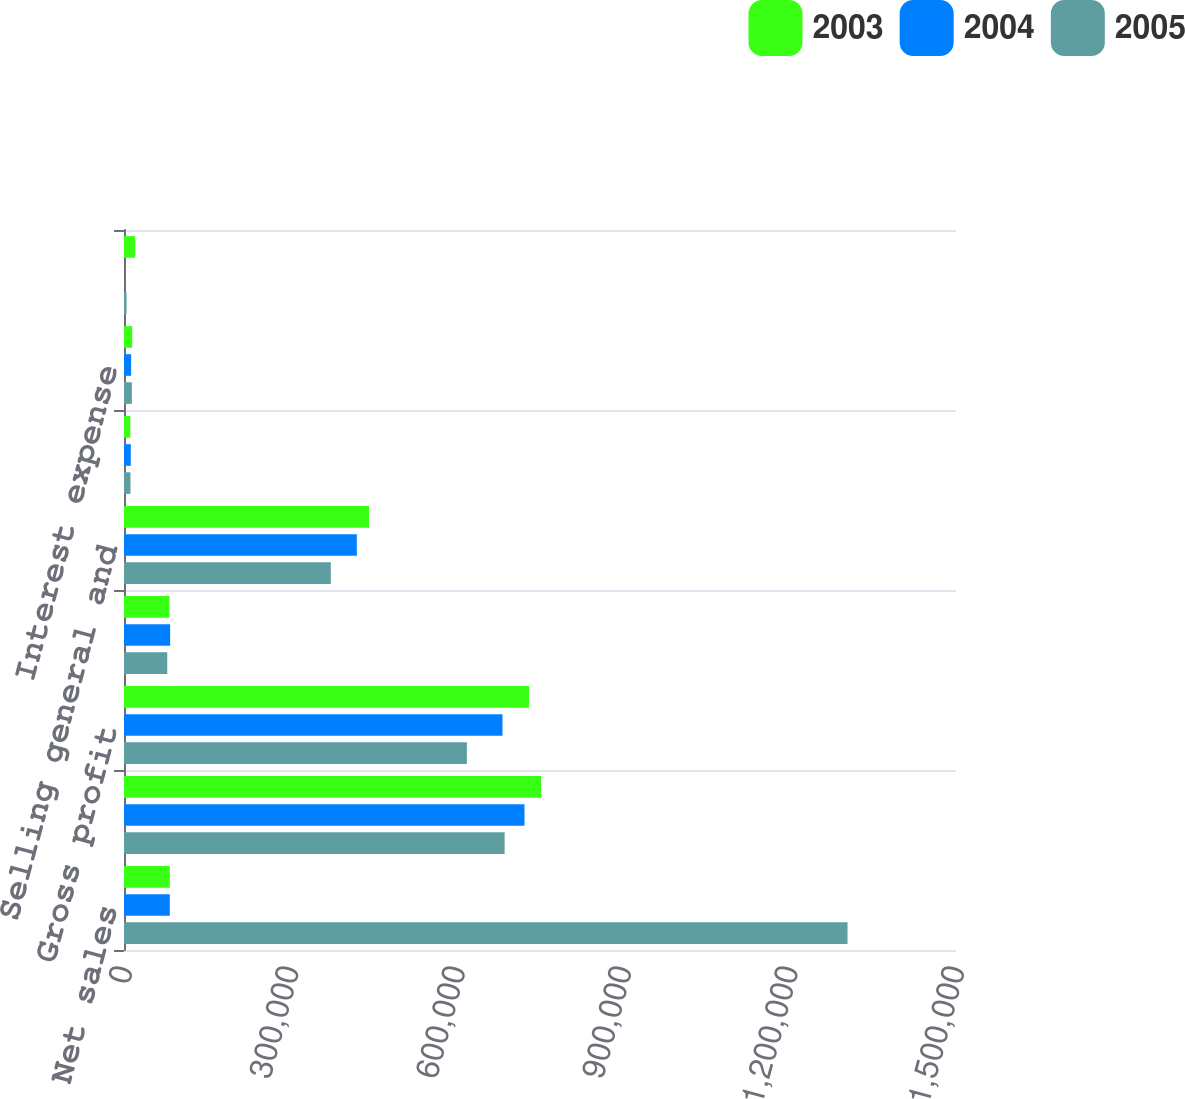Convert chart. <chart><loc_0><loc_0><loc_500><loc_500><stacked_bar_chart><ecel><fcel>Net sales<fcel>Cost of sales<fcel>Gross profit<fcel>Research and development<fcel>Selling general and<fcel>Amortization<fcel>Interest expense<fcel>Other charges net ^(b)<nl><fcel>2003<fcel>82555<fcel>752153<fcel>730319<fcel>81893<fcel>441702<fcel>11436<fcel>14880<fcel>20224<nl><fcel>2004<fcel>82555<fcel>722047<fcel>682407<fcel>83217<fcel>419780<fcel>12256<fcel>12888<fcel>42<nl><fcel>2005<fcel>1.30443e+06<fcel>686255<fcel>618176<fcel>78003<fcel>372822<fcel>11724<fcel>14153<fcel>4563<nl></chart> 